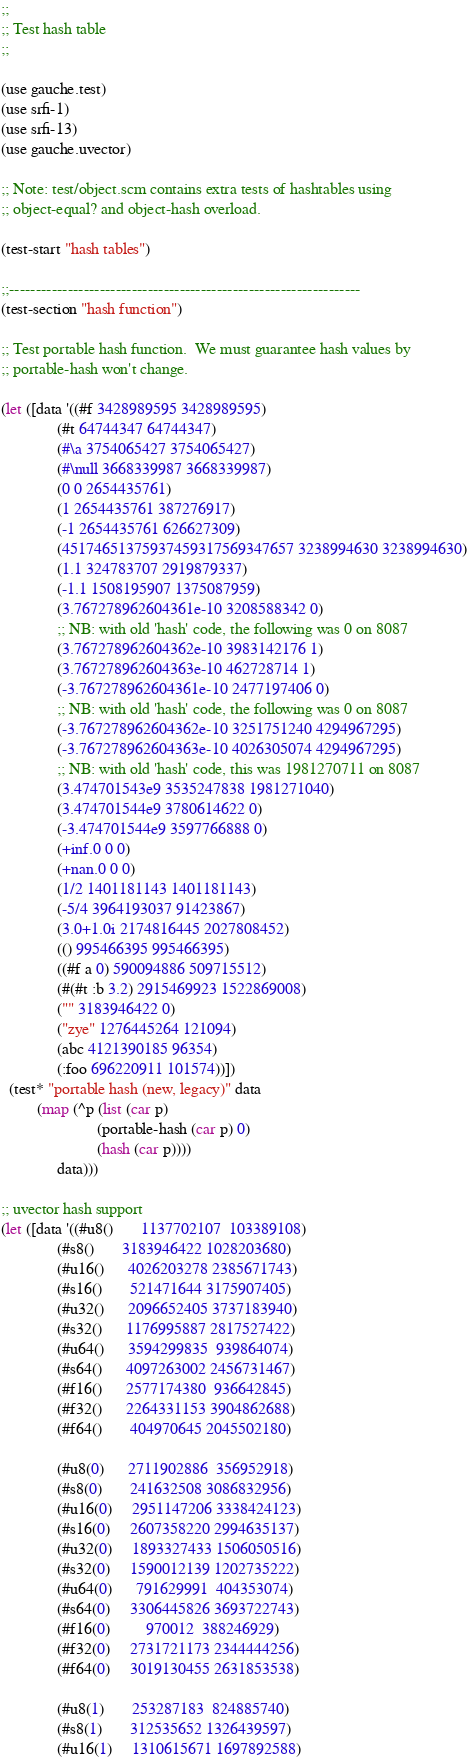<code> <loc_0><loc_0><loc_500><loc_500><_Scheme_>;;
;; Test hash table
;;

(use gauche.test)
(use srfi-1)
(use srfi-13)
(use gauche.uvector)

;; Note: test/object.scm contains extra tests of hashtables using
;; object-equal? and object-hash overload.

(test-start "hash tables")

;;------------------------------------------------------------------
(test-section "hash function")

;; Test portable hash function.  We must guarantee hash values by
;; portable-hash won't change.

(let ([data '((#f 3428989595 3428989595)
              (#t 64744347 64744347)
              (#\a 3754065427 3754065427)
              (#\null 3668339987 3668339987)
              (0 0 2654435761)
              (1 2654435761 387276917)
              (-1 2654435761 626627309)
              (45174651375937459317569347657 3238994630 3238994630)
              (1.1 324783707 2919879337)
              (-1.1 1508195907 1375087959)
              (3.767278962604361e-10 3208588342 0)
              ;; NB: with old 'hash' code, the following was 0 on 8087
              (3.767278962604362e-10 3983142176 1)
              (3.767278962604363e-10 462728714 1)
              (-3.767278962604361e-10 2477197406 0)
              ;; NB: with old 'hash' code, the following was 0 on 8087
              (-3.767278962604362e-10 3251751240 4294967295)
              (-3.767278962604363e-10 4026305074 4294967295)
              ;; NB: with old 'hash' code, this was 1981270711 on 8087
              (3.474701543e9 3535247838 1981271040)
              (3.474701544e9 3780614622 0)
              (-3.474701544e9 3597766888 0)
              (+inf.0 0 0)
              (+nan.0 0 0)
              (1/2 1401181143 1401181143)
              (-5/4 3964193037 91423867)
              (3.0+1.0i 2174816445 2027808452)
              (() 995466395 995466395)
              ((#f a 0) 590094886 509715512)
              (#(#t :b 3.2) 2915469923 1522869008)
              ("" 3183946422 0)
              ("zye" 1276445264 121094)
              (abc 4121390185 96354)
              (:foo 696220911 101574))])
  (test* "portable hash (new, legacy)" data
         (map (^p (list (car p)
                        (portable-hash (car p) 0)
                        (hash (car p))))
              data)))

;; uvector hash support
(let ([data '((#u8()       1137702107  103389108)
              (#s8()       3183946422 1028203680)
              (#u16()      4026203278 2385671743)
              (#s16()       521471644 3175907405)
              (#u32()      2096652405 3737183940)
              (#s32()      1176995887 2817527422)
              (#u64()      3594299835  939864074)
              (#s64()      4097263002 2456731467)
              (#f16()      2577174380  936642845)
              (#f32()      2264331153 3904862688)
              (#f64()       404970645 2045502180)

              (#u8(0)      2711902886  356952918)
              (#s8(0)       241632508 3086832956)
              (#u16(0)     2951147206 3338424123)
              (#s16(0)     2607358220 2994635137)
              (#u32(0)     1893327433 1506050516)
              (#s32(0)     1590012139 1202735222)
              (#u64(0)      791629991  404353074)
              (#s64(0)     3306445826 3693722743)
              (#f16(0)         970012  388246929)
              (#f32(0)     2731721173 2344444256)
              (#f64(0)     3019130455 2631853538)

              (#u8(1)       253287183  824885740)
              (#s8(1)       312535652 1326439597)
              (#u16(1)     1310615671 1697892588)</code> 